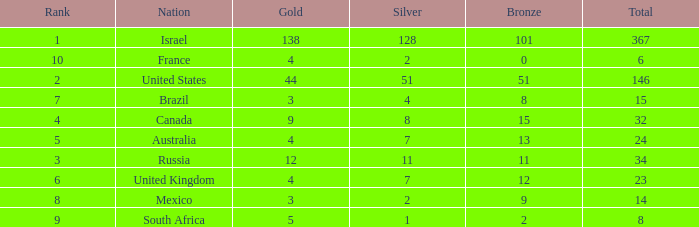What is the maximum number of silvers for a country with fewer than 12 golds and a total less than 8? 2.0. 